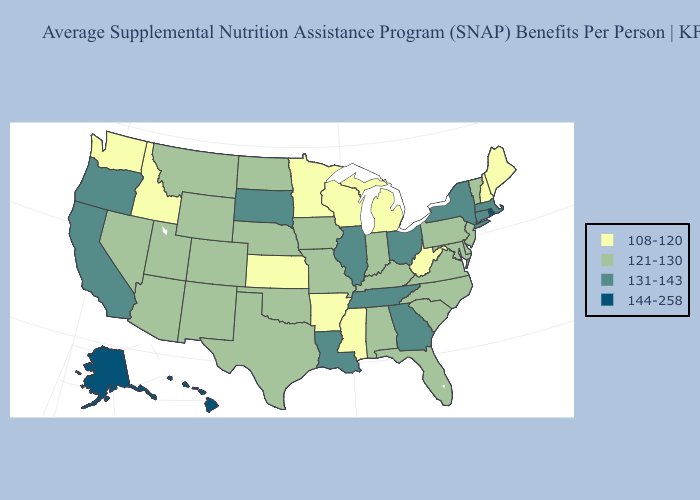What is the value of Virginia?
Give a very brief answer. 121-130. Among the states that border Illinois , does Missouri have the lowest value?
Concise answer only. No. Does Florida have the lowest value in the USA?
Keep it brief. No. Which states have the lowest value in the USA?
Quick response, please. Arkansas, Idaho, Kansas, Maine, Michigan, Minnesota, Mississippi, New Hampshire, Washington, West Virginia, Wisconsin. What is the value of Florida?
Be succinct. 121-130. What is the value of Tennessee?
Quick response, please. 131-143. What is the value of South Dakota?
Answer briefly. 131-143. Does the map have missing data?
Write a very short answer. No. Does the first symbol in the legend represent the smallest category?
Write a very short answer. Yes. What is the value of Florida?
Concise answer only. 121-130. Which states hav the highest value in the West?
Quick response, please. Alaska, Hawaii. Which states hav the highest value in the MidWest?
Quick response, please. Illinois, Ohio, South Dakota. What is the value of Vermont?
Keep it brief. 121-130. Name the states that have a value in the range 108-120?
Quick response, please. Arkansas, Idaho, Kansas, Maine, Michigan, Minnesota, Mississippi, New Hampshire, Washington, West Virginia, Wisconsin. Which states have the lowest value in the Northeast?
Short answer required. Maine, New Hampshire. 